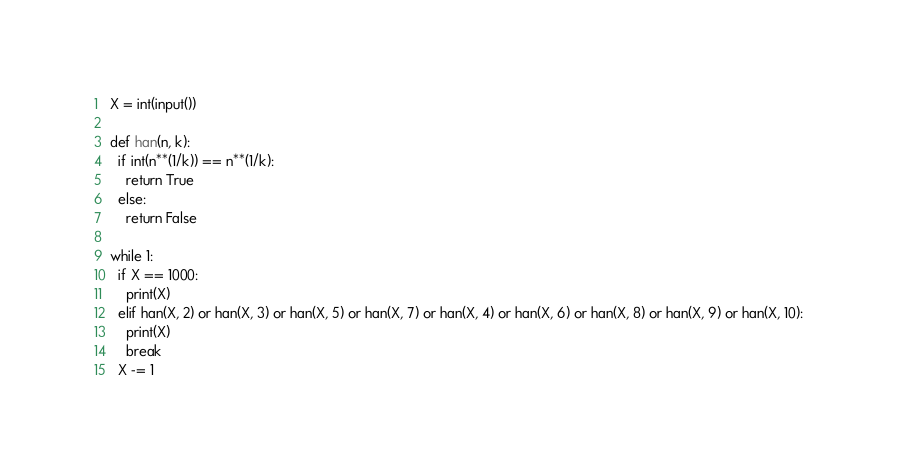Convert code to text. <code><loc_0><loc_0><loc_500><loc_500><_Python_>X = int(input())

def han(n, k):
  if int(n**(1/k)) == n**(1/k):
    return True
  else:
    return False
  
while 1:
  if X == 1000:
    print(X)
  elif han(X, 2) or han(X, 3) or han(X, 5) or han(X, 7) or han(X, 4) or han(X, 6) or han(X, 8) or han(X, 9) or han(X, 10):
    print(X)
    break
  X -= 1





</code> 